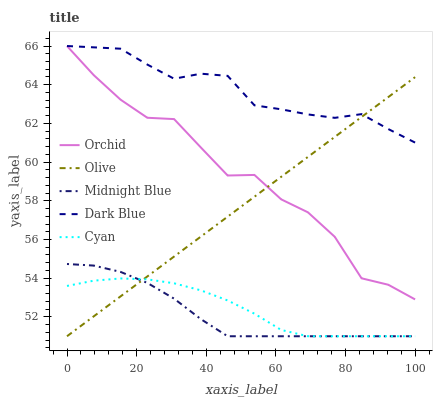Does Midnight Blue have the minimum area under the curve?
Answer yes or no. Yes. Does Dark Blue have the maximum area under the curve?
Answer yes or no. Yes. Does Cyan have the minimum area under the curve?
Answer yes or no. No. Does Cyan have the maximum area under the curve?
Answer yes or no. No. Is Olive the smoothest?
Answer yes or no. Yes. Is Orchid the roughest?
Answer yes or no. Yes. Is Dark Blue the smoothest?
Answer yes or no. No. Is Dark Blue the roughest?
Answer yes or no. No. Does Olive have the lowest value?
Answer yes or no. Yes. Does Dark Blue have the lowest value?
Answer yes or no. No. Does Orchid have the highest value?
Answer yes or no. Yes. Does Cyan have the highest value?
Answer yes or no. No. Is Cyan less than Orchid?
Answer yes or no. Yes. Is Orchid greater than Midnight Blue?
Answer yes or no. Yes. Does Olive intersect Dark Blue?
Answer yes or no. Yes. Is Olive less than Dark Blue?
Answer yes or no. No. Is Olive greater than Dark Blue?
Answer yes or no. No. Does Cyan intersect Orchid?
Answer yes or no. No. 